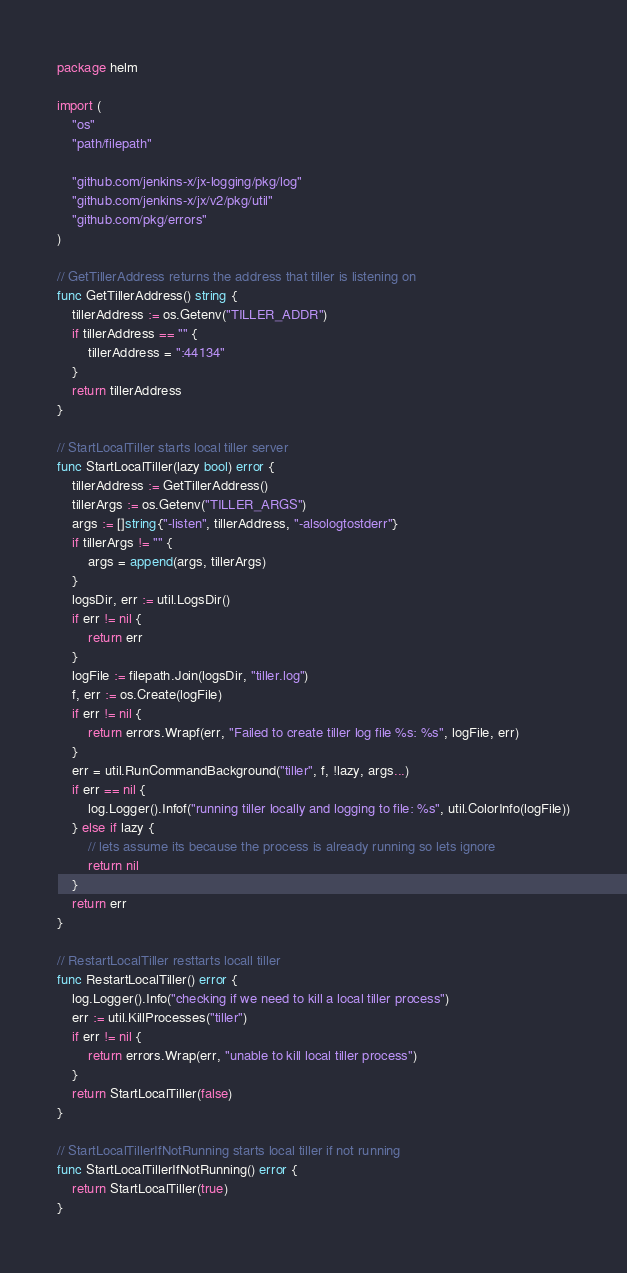Convert code to text. <code><loc_0><loc_0><loc_500><loc_500><_Go_>package helm

import (
	"os"
	"path/filepath"

	"github.com/jenkins-x/jx-logging/pkg/log"
	"github.com/jenkins-x/jx/v2/pkg/util"
	"github.com/pkg/errors"
)

// GetTillerAddress returns the address that tiller is listening on
func GetTillerAddress() string {
	tillerAddress := os.Getenv("TILLER_ADDR")
	if tillerAddress == "" {
		tillerAddress = ":44134"
	}
	return tillerAddress
}

// StartLocalTiller starts local tiller server
func StartLocalTiller(lazy bool) error {
	tillerAddress := GetTillerAddress()
	tillerArgs := os.Getenv("TILLER_ARGS")
	args := []string{"-listen", tillerAddress, "-alsologtostderr"}
	if tillerArgs != "" {
		args = append(args, tillerArgs)
	}
	logsDir, err := util.LogsDir()
	if err != nil {
		return err
	}
	logFile := filepath.Join(logsDir, "tiller.log")
	f, err := os.Create(logFile)
	if err != nil {
		return errors.Wrapf(err, "Failed to create tiller log file %s: %s", logFile, err)
	}
	err = util.RunCommandBackground("tiller", f, !lazy, args...)
	if err == nil {
		log.Logger().Infof("running tiller locally and logging to file: %s", util.ColorInfo(logFile))
	} else if lazy {
		// lets assume its because the process is already running so lets ignore
		return nil
	}
	return err
}

// RestartLocalTiller resttarts locall tiller
func RestartLocalTiller() error {
	log.Logger().Info("checking if we need to kill a local tiller process")
	err := util.KillProcesses("tiller")
	if err != nil {
		return errors.Wrap(err, "unable to kill local tiller process")
	}
	return StartLocalTiller(false)
}

// StartLocalTillerIfNotRunning starts local tiller if not running
func StartLocalTillerIfNotRunning() error {
	return StartLocalTiller(true)
}
</code> 